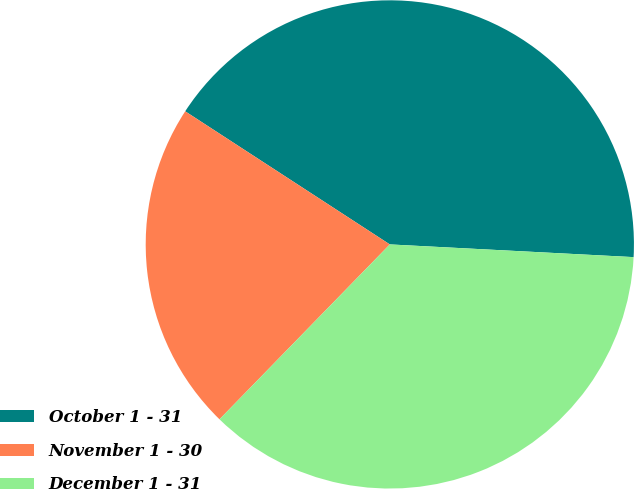Convert chart. <chart><loc_0><loc_0><loc_500><loc_500><pie_chart><fcel>October 1 - 31<fcel>November 1 - 30<fcel>December 1 - 31<nl><fcel>41.65%<fcel>21.89%<fcel>36.46%<nl></chart> 